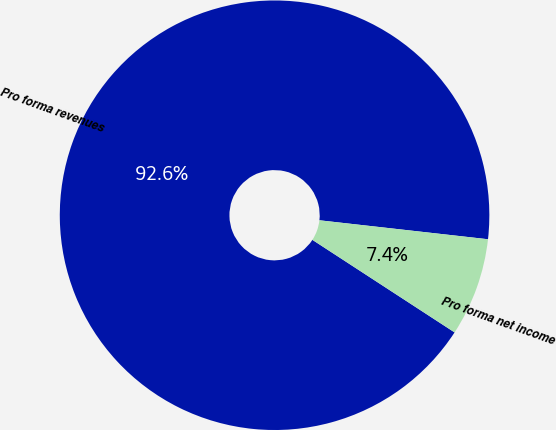Convert chart. <chart><loc_0><loc_0><loc_500><loc_500><pie_chart><fcel>Pro forma revenues<fcel>Pro forma net income<nl><fcel>92.6%<fcel>7.4%<nl></chart> 